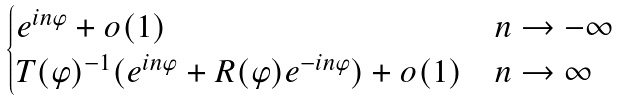<formula> <loc_0><loc_0><loc_500><loc_500>\begin{cases} e ^ { i n \varphi } + o ( 1 ) & n \to - \infty \\ T ( \varphi ) ^ { - 1 } ( e ^ { i n \varphi } + R ( \varphi ) e ^ { - i n \varphi } ) + o ( 1 ) & n \to \infty \end{cases}</formula> 